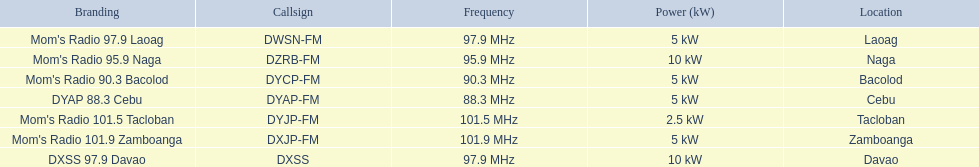Are there any stations that operate with less than 10kw of power? Mom's Radio 97.9 Laoag, Mom's Radio 90.3 Bacolod, DYAP 88.3 Cebu, Mom's Radio 101.5 Tacloban, Mom's Radio 101.9 Zamboanga. Additionally, do any stations function with less than 5kw of power, and if so, can you identify them? Mom's Radio 101.5 Tacloban. 